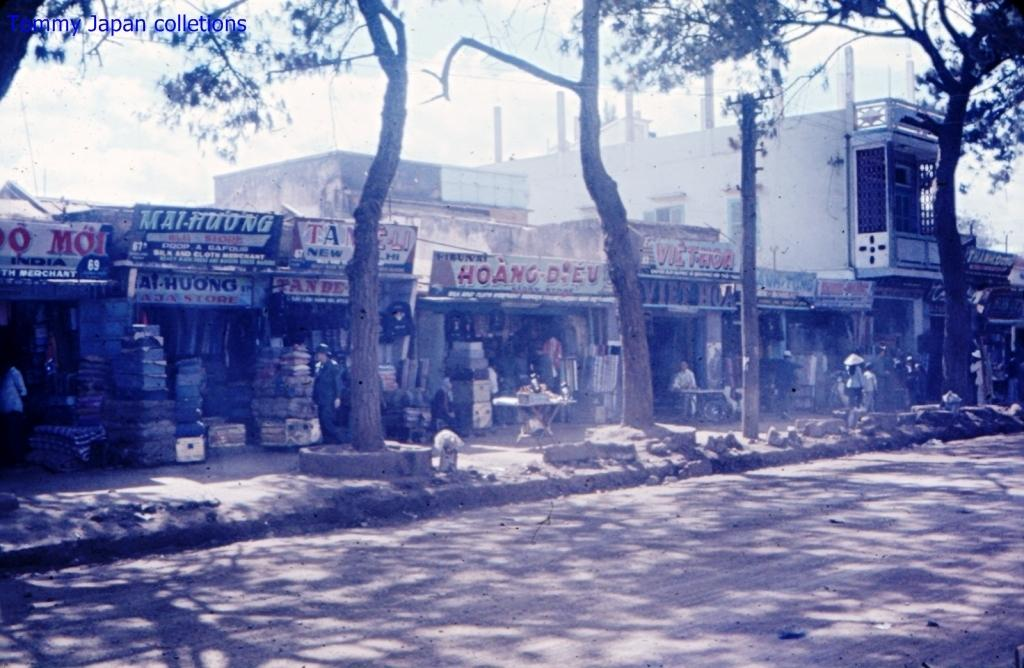What type of pathway is visible in the image? There is a road in the image. What natural elements can be seen in the image? There are stones, trees, and the sky visible in the image. What man-made structures are present in the image? There are buildings in the image. Are there any decorative elements in the image? Yes, there are banners in the image. What other objects can be seen in the image? There are other objects in the image, but their specific details are not mentioned in the provided facts. What type of celery is being used as a decoration on the banners in the image? There is no celery present in the image; it is a road with stones, trees, buildings, banners, and other objects. Can you tell me how many carriages are parked near the buildings in the image? There is no mention of carriages in the image; it features a road, stones, trees, buildings, banners, and other objects. 